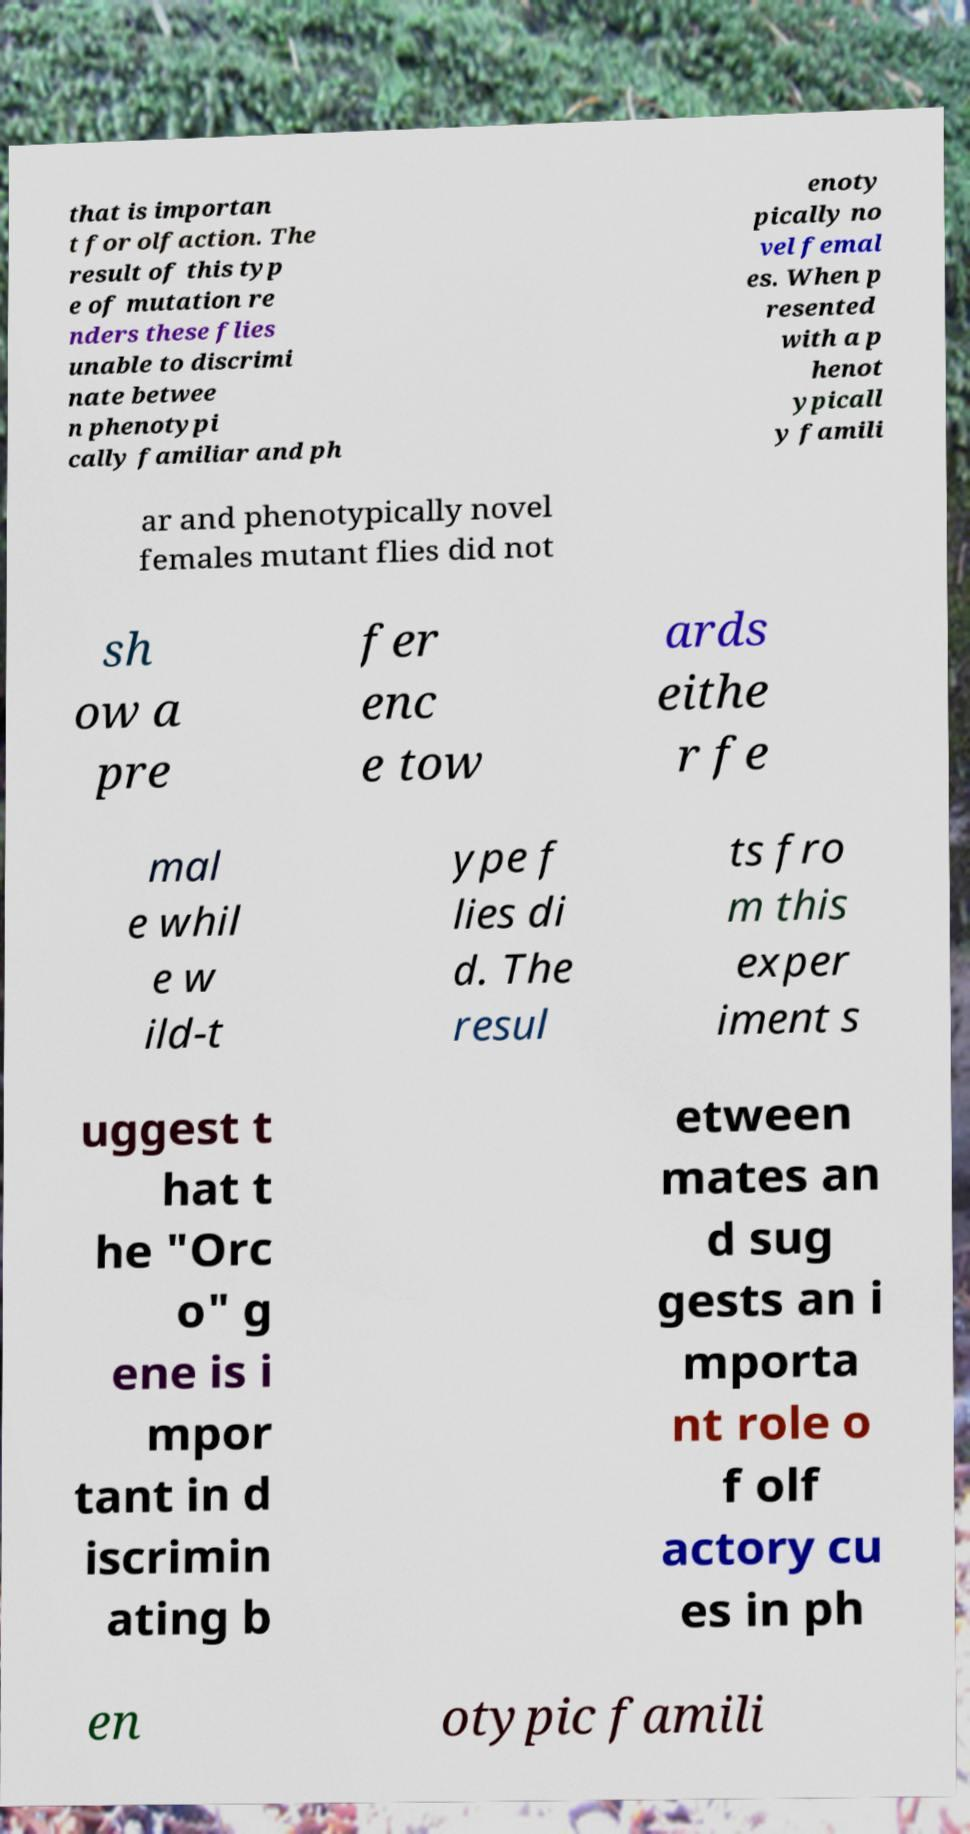For documentation purposes, I need the text within this image transcribed. Could you provide that? that is importan t for olfaction. The result of this typ e of mutation re nders these flies unable to discrimi nate betwee n phenotypi cally familiar and ph enoty pically no vel femal es. When p resented with a p henot ypicall y famili ar and phenotypically novel females mutant flies did not sh ow a pre fer enc e tow ards eithe r fe mal e whil e w ild-t ype f lies di d. The resul ts fro m this exper iment s uggest t hat t he "Orc o" g ene is i mpor tant in d iscrimin ating b etween mates an d sug gests an i mporta nt role o f olf actory cu es in ph en otypic famili 